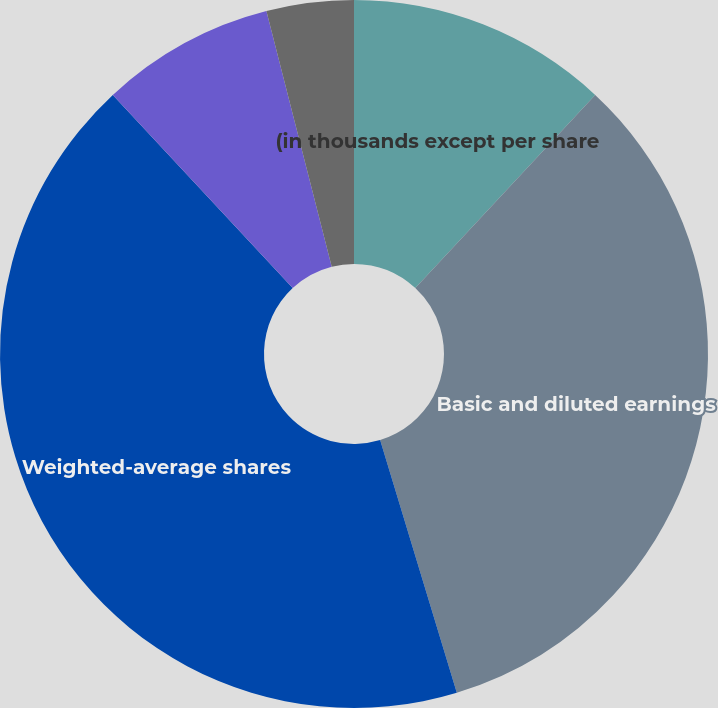Convert chart. <chart><loc_0><loc_0><loc_500><loc_500><pie_chart><fcel>(in thousands except per share<fcel>Basic and diluted earnings<fcel>Weighted-average shares<fcel>Employee Stock Options<fcel>Basic income per common share<fcel>Diluted income per common<nl><fcel>11.93%<fcel>33.38%<fcel>42.76%<fcel>7.95%<fcel>3.98%<fcel>0.0%<nl></chart> 